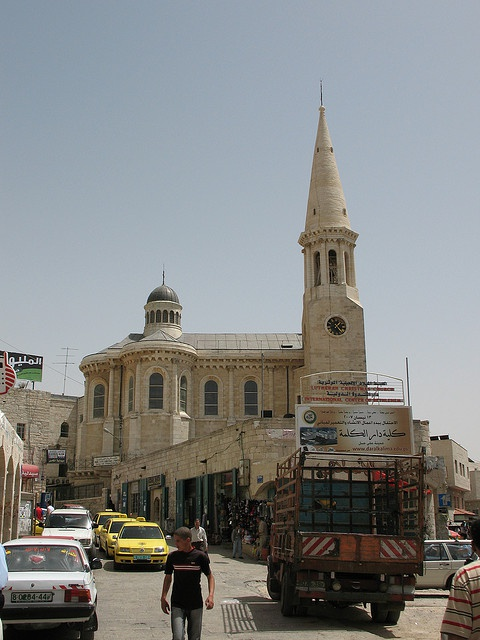Describe the objects in this image and their specific colors. I can see truck in gray, black, and maroon tones, car in gray, black, lightgray, and darkgray tones, people in gray, black, maroon, and darkgray tones, people in gray, black, and maroon tones, and car in gray, black, khaki, and olive tones in this image. 